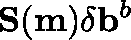<formula> <loc_0><loc_0><loc_500><loc_500>S ( m ) \delta b ^ { b }</formula> 